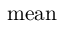Convert formula to latex. <formula><loc_0><loc_0><loc_500><loc_500>m e a n</formula> 